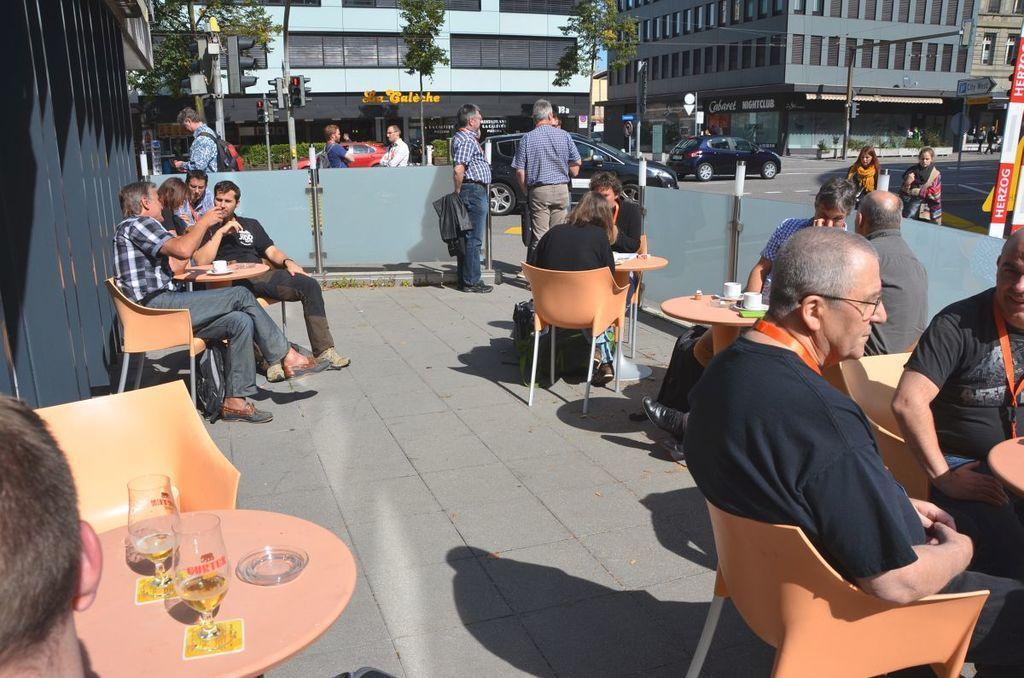Could you give a brief overview of what you see in this image? This image is taken outdoors. At the bottom of the image there is a floor. In the background there are a few buildings with walls, windows, doors and roofs. There are many boards with text on them. There are a few poles with street lights and there are two signal lights. There are a few plants and there is a sign board. A few cars are moving on the road. A few people are walking. In the middle of the image a few people are sitting on the chairs and there are a few tables with a few things on them. A few are standing and two women are walking. 